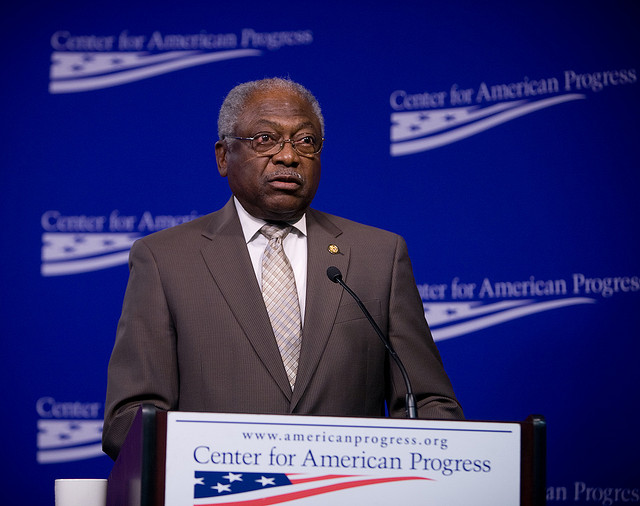Please identify all text content in this image. www.americanprogress.org Center for American Progress Progres American for Center Center for Progres American Progres Center American for Center Progress American for Center 